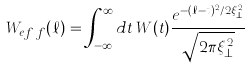Convert formula to latex. <formula><loc_0><loc_0><loc_500><loc_500>W _ { e f \, f } ( \ell ) = \int _ { - \infty } ^ { \infty } d t \, W ( t ) \frac { e ^ { - ( \ell - t ) ^ { 2 } / 2 \xi _ { \bot } ^ { 2 } } } { \sqrt { 2 \pi \xi _ { \bot } ^ { 2 } } }</formula> 